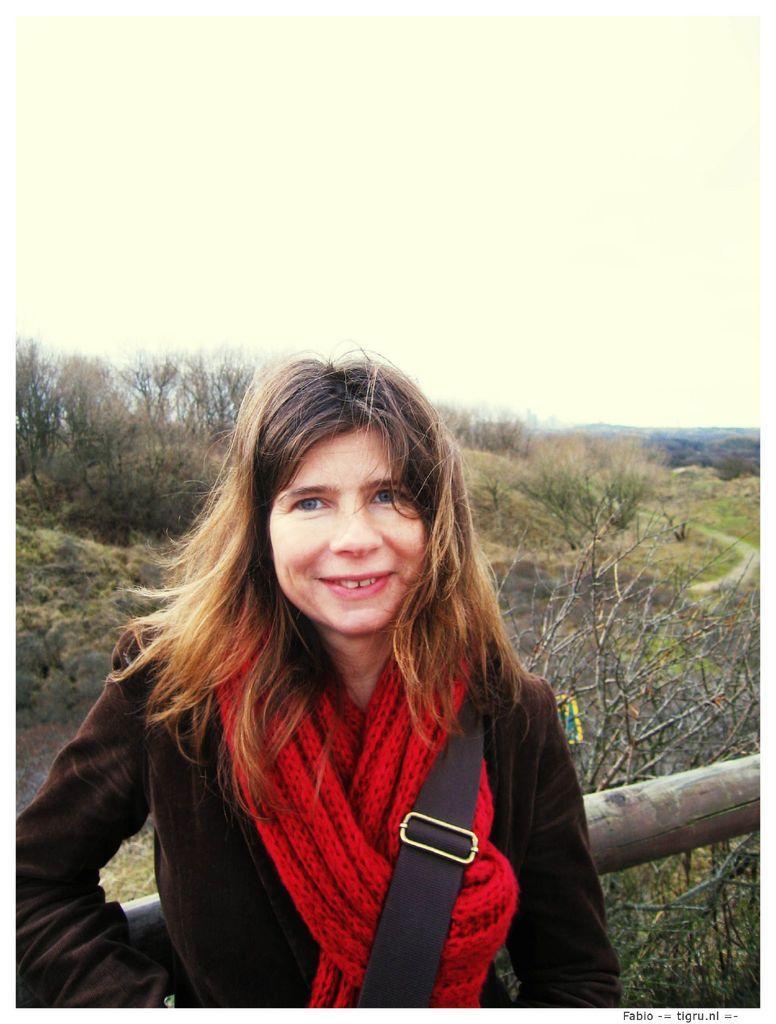Describe this image in one or two sentences. In the foreground of this image, there is a woman wearing a bag and a red scarf is standing by leaning to a wood. In the background, there are trees, a path and the sky. 